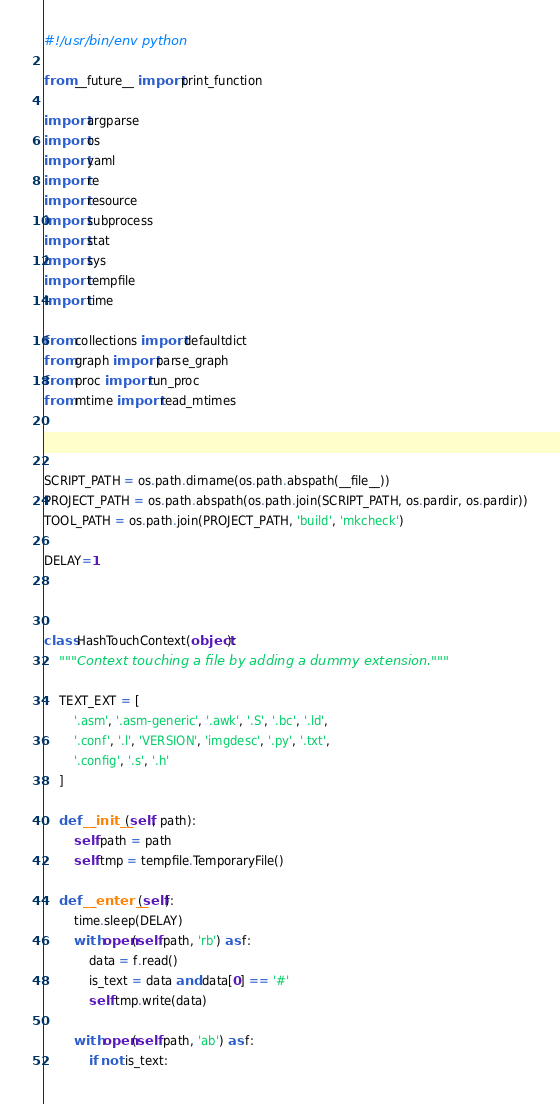<code> <loc_0><loc_0><loc_500><loc_500><_Python_>#!/usr/bin/env python

from __future__ import print_function

import argparse
import os
import yaml
import re
import resource
import subprocess
import stat
import sys
import tempfile
import time

from collections import defaultdict
from graph import parse_graph
from proc import run_proc
from mtime import read_mtimes



SCRIPT_PATH = os.path.dirname(os.path.abspath(__file__))
PROJECT_PATH = os.path.abspath(os.path.join(SCRIPT_PATH, os.pardir, os.pardir))
TOOL_PATH = os.path.join(PROJECT_PATH, 'build', 'mkcheck')

DELAY=1



class HashTouchContext(object):
    """Context touching a file by adding a dummy extension."""

    TEXT_EXT = [
        '.asm', '.asm-generic', '.awk', '.S', '.bc', '.ld',
        '.conf', '.l', 'VERSION', 'imgdesc', '.py', '.txt',
        '.config', '.s', '.h'
    ]

    def __init__(self, path):
        self.path = path
        self.tmp = tempfile.TemporaryFile()
    
    def __enter__(self):
        time.sleep(DELAY)
        with open(self.path, 'rb') as f:
            data = f.read()
            is_text = data and data[0] == '#'
            self.tmp.write(data)

        with open(self.path, 'ab') as f:
            if not is_text:</code> 